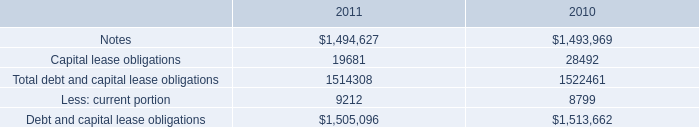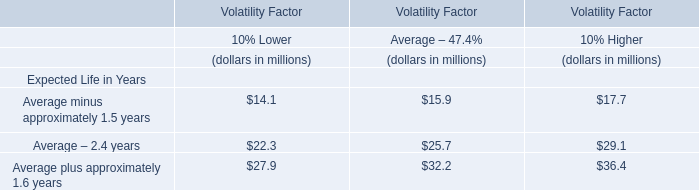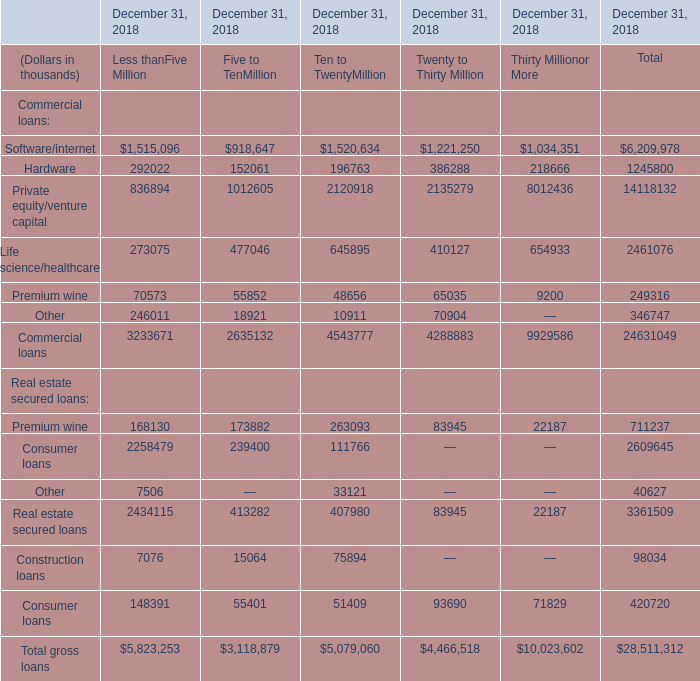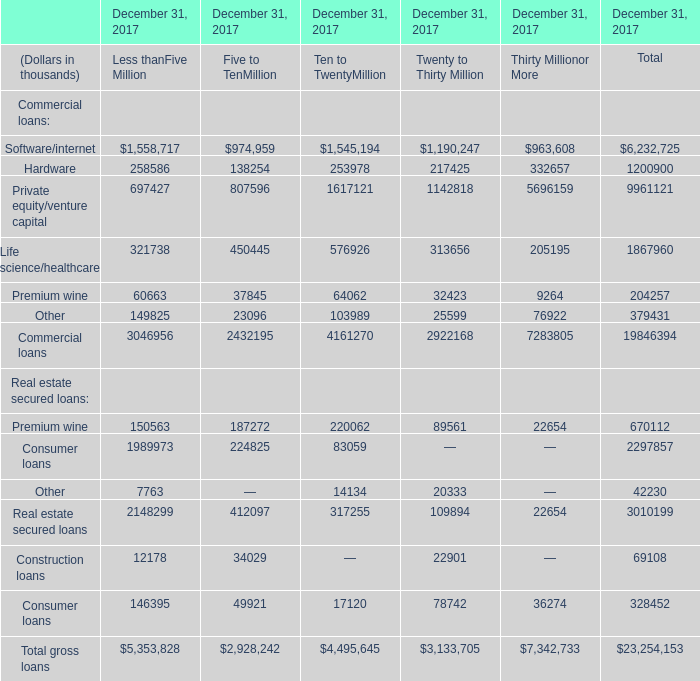What is the ratio of Other to the total in 2018? 
Computations: (346747 / ((24631049 + 28511312) + 3361509))
Answer: 0.00614. 